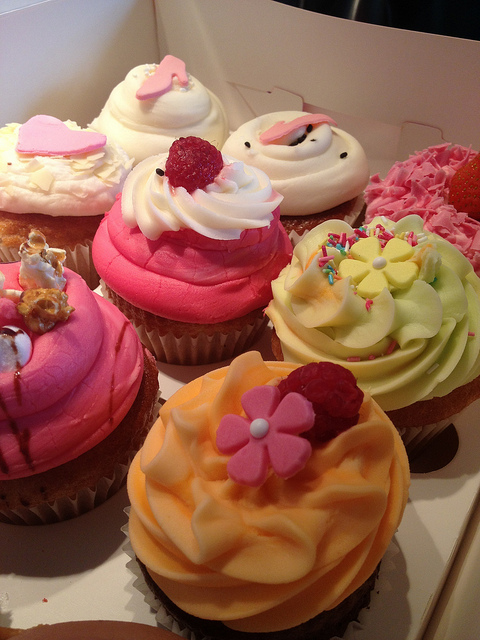Which cupcake seems to be the most popular based on its decoration? While popularity is subjective, the cupcake with the bright pink frosting and a fresh raspberry on top might be particularly appealing. It's visually striking and suggests a fresh fruit flavor that many might find enticing. The raspberry serves as both a hint of flavor and a beautiful natural garnish. 